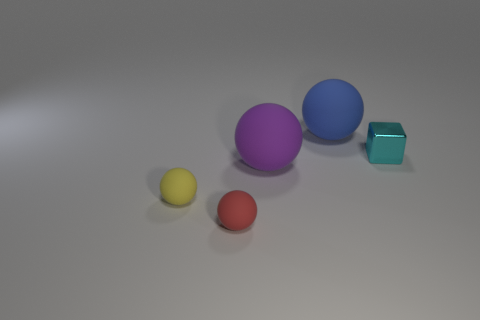Is the material of the purple ball the same as the tiny thing that is to the right of the blue object?
Offer a very short reply. No. What size is the purple thing that is made of the same material as the tiny red ball?
Your answer should be very brief. Large. There is a matte sphere on the left side of the red thing; what is its size?
Your response must be concise. Small. How many other cyan metal cubes are the same size as the cyan metallic block?
Your answer should be compact. 0. Are there any small matte things of the same color as the metallic block?
Keep it short and to the point. No. What is the color of the object that is the same size as the blue rubber sphere?
Your answer should be very brief. Purple. Is the color of the cube the same as the matte ball that is to the left of the small red rubber thing?
Offer a terse response. No. What color is the metallic thing?
Offer a terse response. Cyan. There is a thing behind the cyan cube; what is its material?
Make the answer very short. Rubber. There is a blue object that is the same shape as the yellow matte thing; what is its size?
Offer a very short reply. Large. 